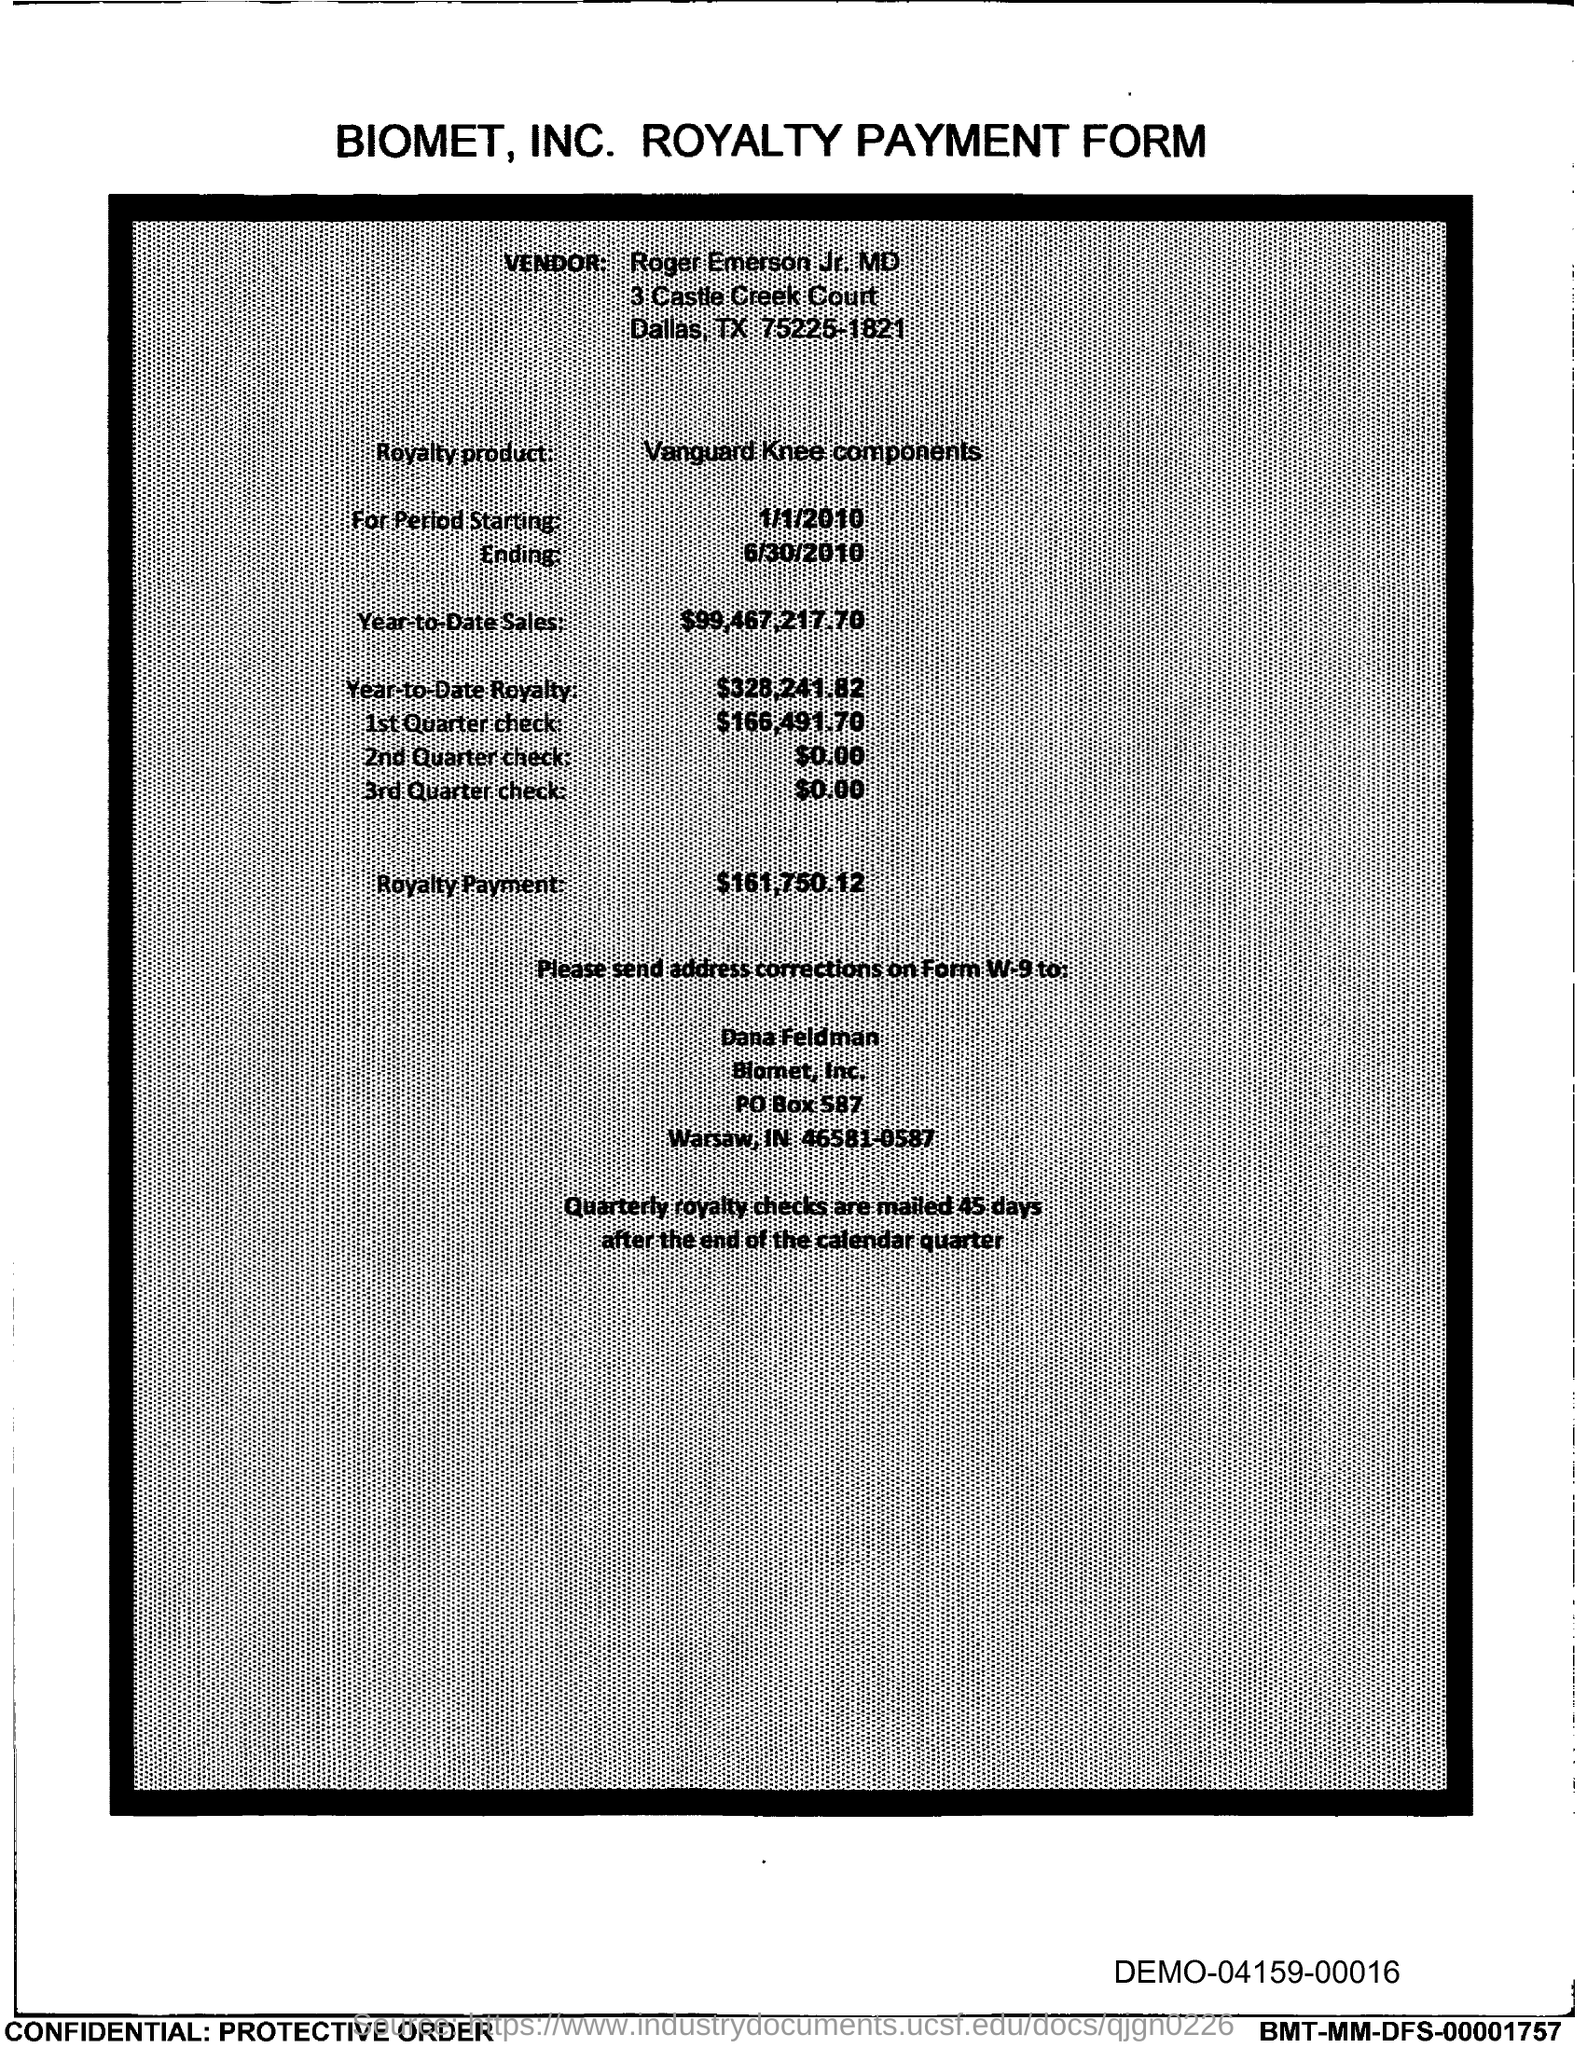Highlight a few significant elements in this photo. The PO Box number mentioned in the document is 587. 